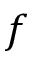<formula> <loc_0><loc_0><loc_500><loc_500>f</formula> 